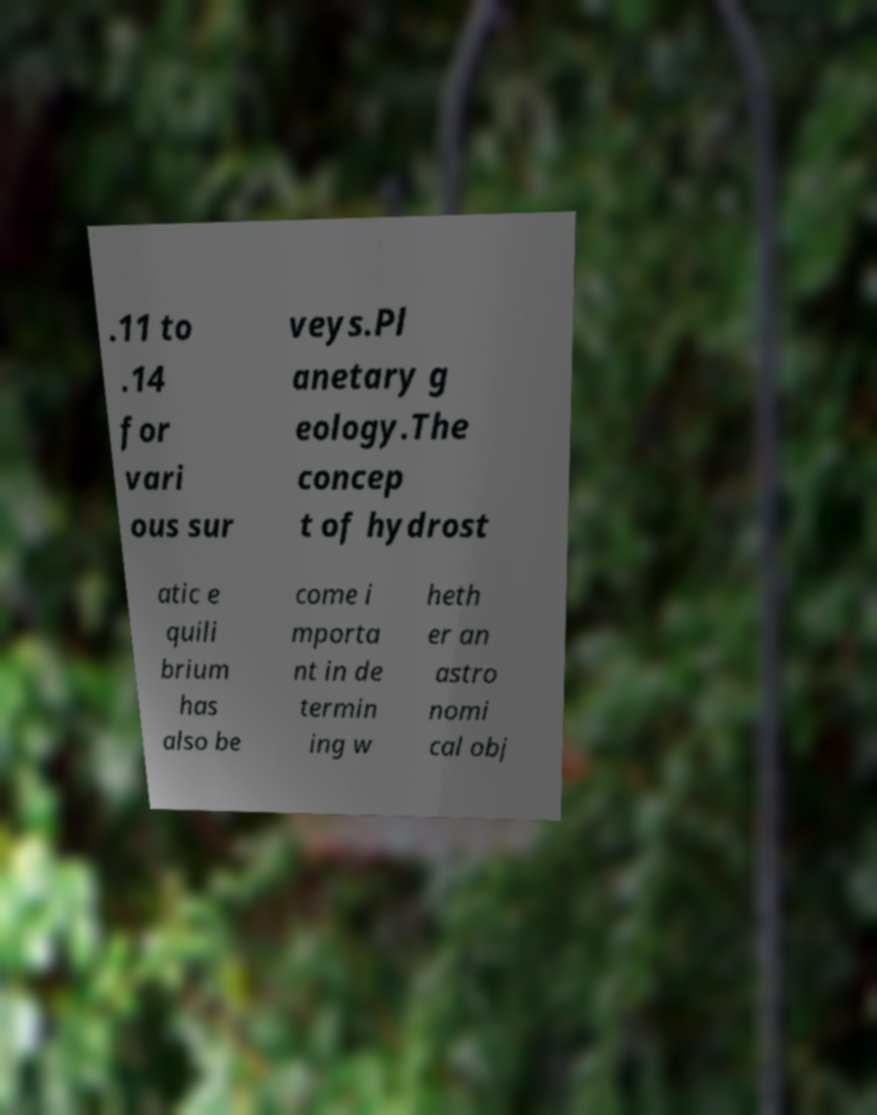There's text embedded in this image that I need extracted. Can you transcribe it verbatim? .11 to .14 for vari ous sur veys.Pl anetary g eology.The concep t of hydrost atic e quili brium has also be come i mporta nt in de termin ing w heth er an astro nomi cal obj 